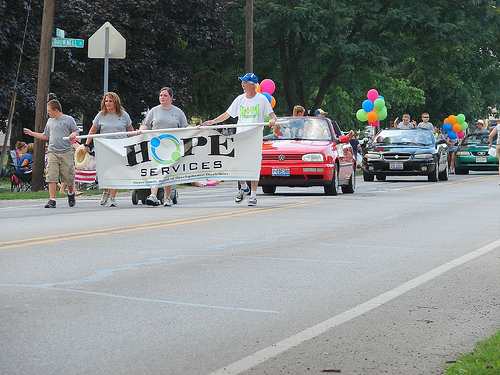<image>
Can you confirm if the car is to the left of the car? No. The car is not to the left of the car. From this viewpoint, they have a different horizontal relationship. Is there a car behind the tree? No. The car is not behind the tree. From this viewpoint, the car appears to be positioned elsewhere in the scene. 